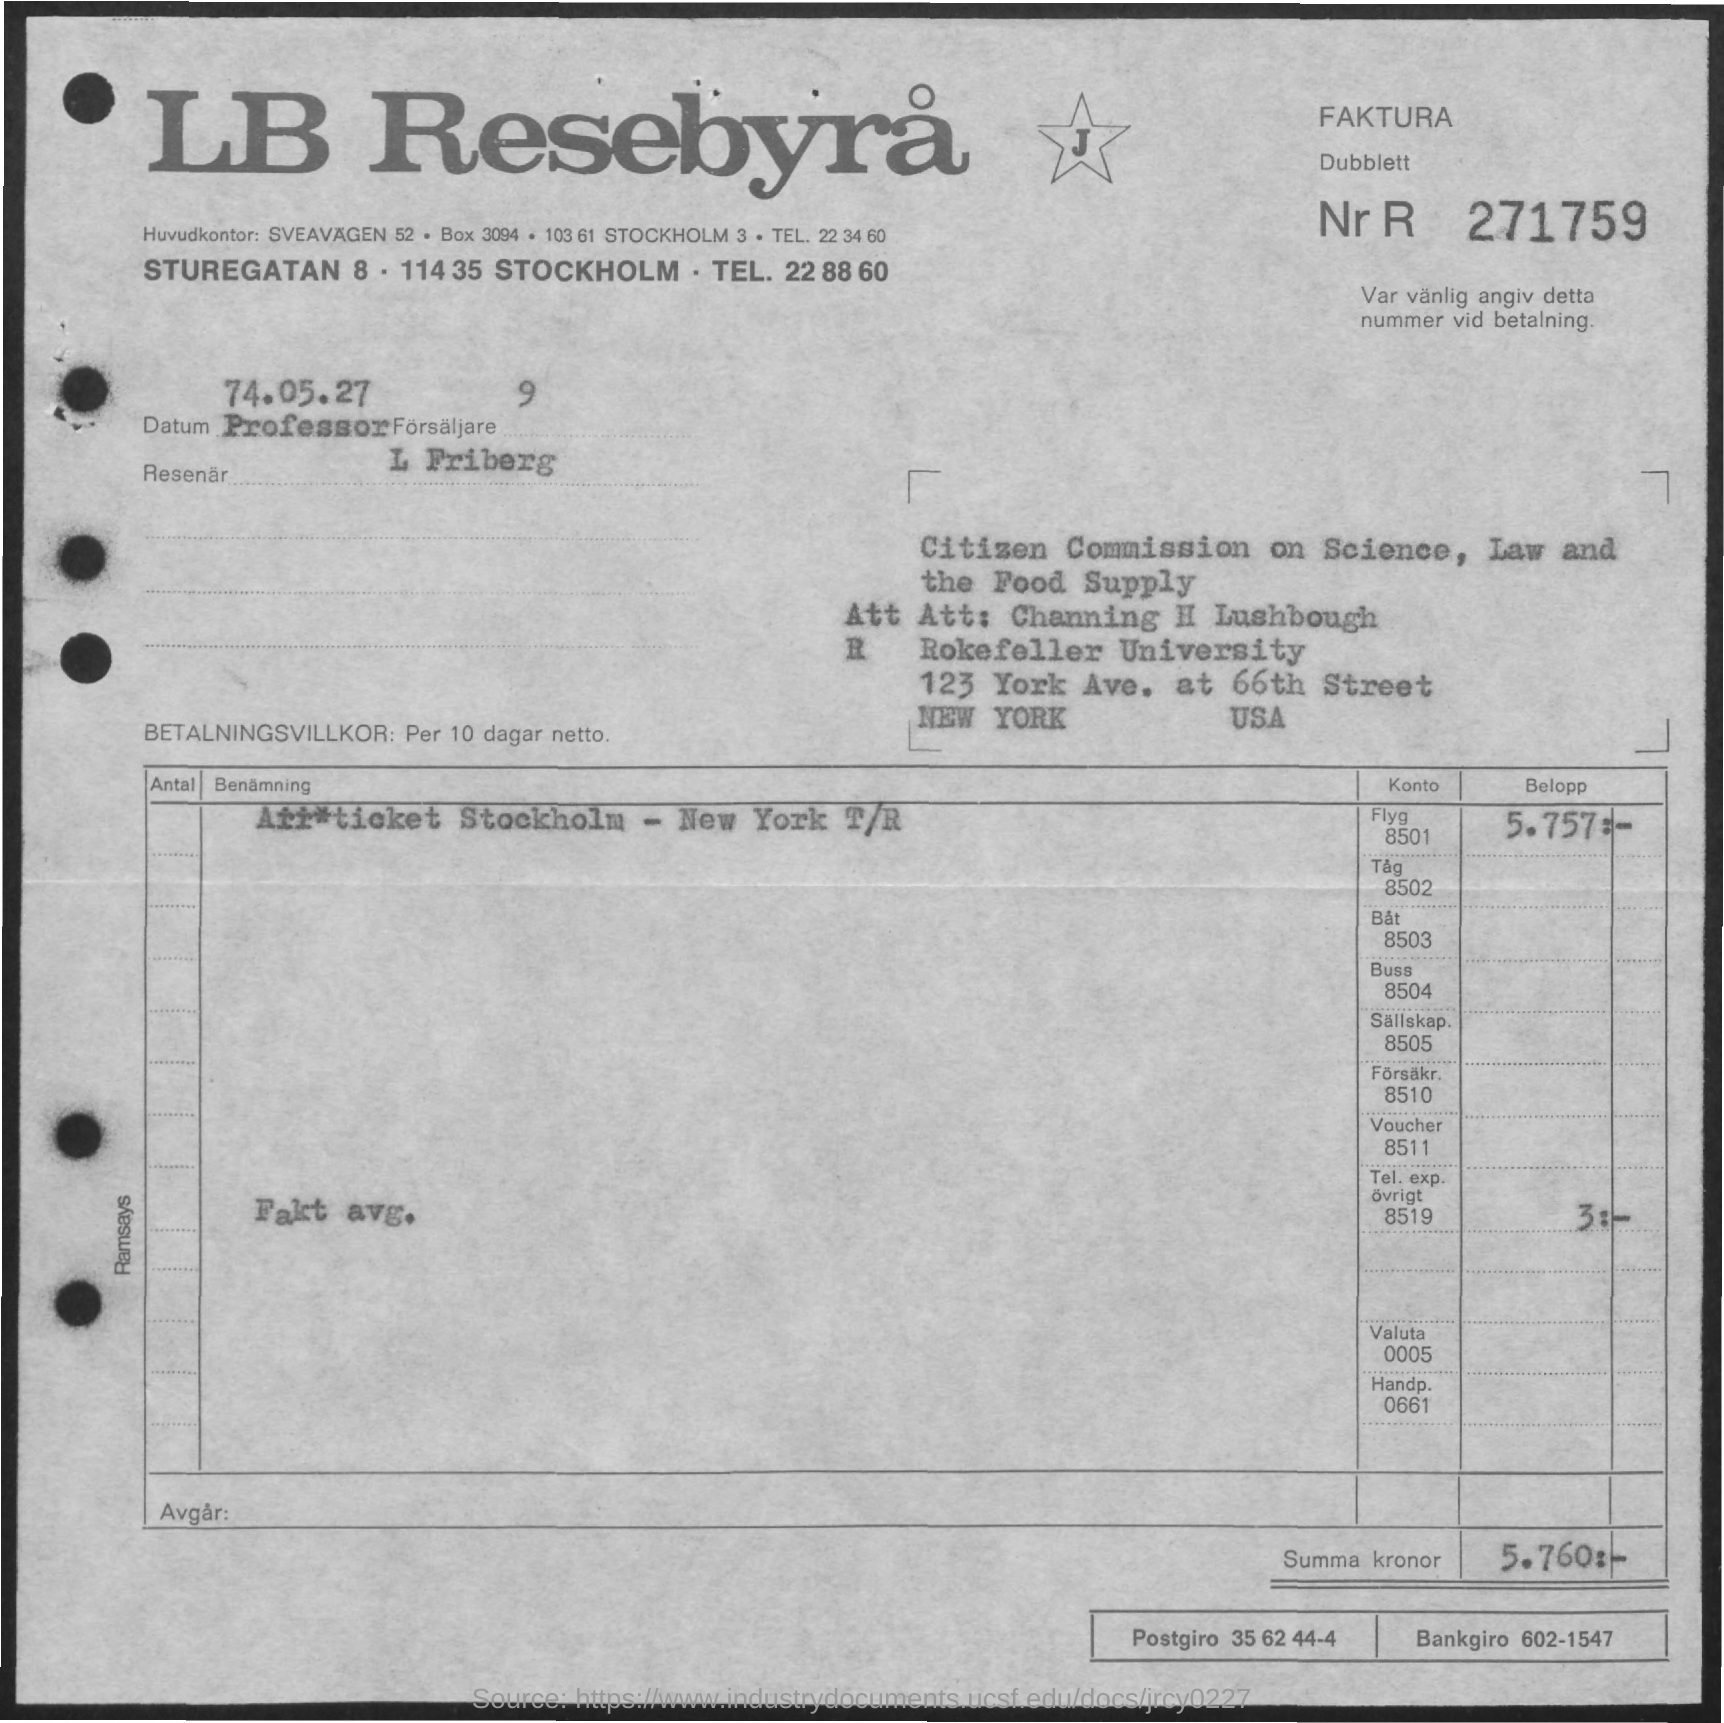What is the title of the document?
Give a very brief answer. LB Resebyra. What is the Summa kronor?
Your answer should be very brief. 5.760. What is the Postgiro?
Make the answer very short. 35 62 44-4. What is the Bankgiro?
Your response must be concise. 602-1547. 